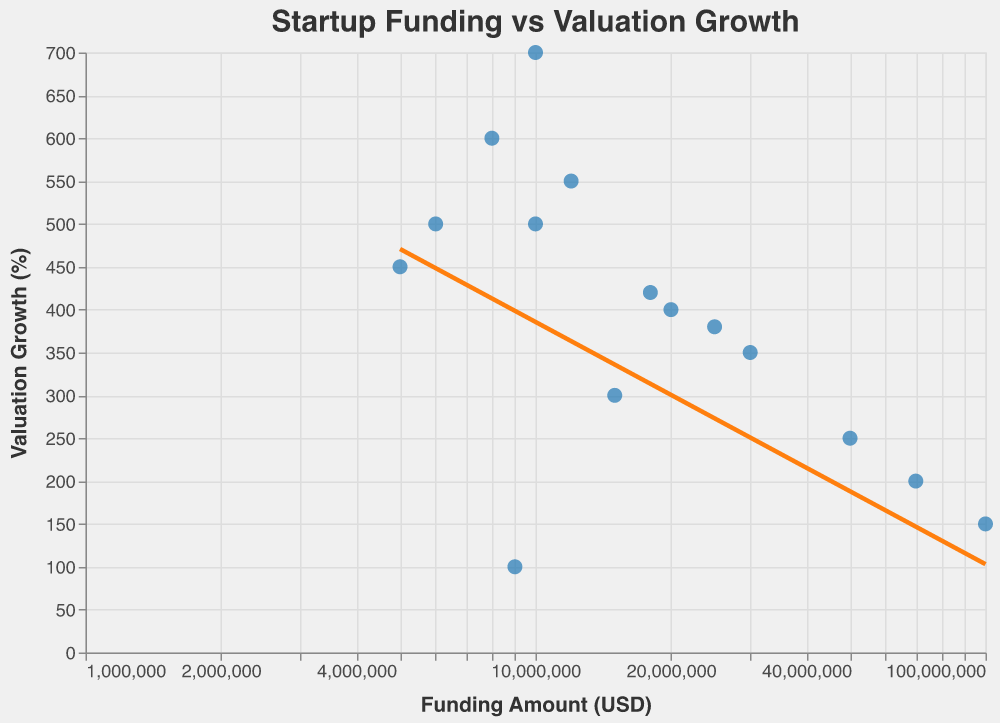What is the funding amount with the highest valuation growth? The funding amount with the highest valuation growth corresponds to the data point where "Funding Amount (USD)" has the highest y-value on the vertical axis, which is at 700% valuation growth for SpaceX with $10,000,000.
Answer: $10,000,000 Which startup received the highest funding amount? The highest funding amount can be identified by locating the rightmost data point on the x-axis, which is for Snapchat with $100,000,000.
Answer: Snapchat What is the trend in valuation growth as funding amount increases? The trend line in the scatter plot generally slopes downwards, indicating a negative correlation between funding amount and valuation growth percentage. Valuation growth tends to decrease as funding amount increases.
Answer: Negative correlation How many startups received more than $20,000,000 in funding? Count the number of data points to the right of the $20,000,000 mark on the x-axis. There are five: Airbnb, Slack, Dropbox, Coinbase, Snapchat, and Lyft.
Answer: 6 What is the valuation growth percentage of the startup with the lowest funding amount? Locate the leftmost data point on the x-axis, which corresponds to Stripe with $5,000,000 in funding, and note its y-value. Its valuation growth percentage is 450%.
Answer: 450% Which startup has a higher valuation growth, Uber or Airbnb? Compare the y-values of the data points for Uber and Airbnb. Uber has a higher valuation growth percentage (600%) compared to Airbnb (400%).
Answer: Uber By how much does SpaceX's valuation growth exceed Dropbox's valuation growth? Subtract Dropbox's valuation growth percentage (200%) from SpaceX's valuation growth percentage (700%) to find the difference. 700% - 200% = 500%.
Answer: 500% Which startup has the lowest valuation growth percentage? Identify the data point with the lowest y-value on the vertical axis, which is for WeWork with a valuation growth percentage of 100%.
Answer: WeWork What is the average valuation growth percentage for the startups with funding amounts between $5,000,000 and $20,000,000? Identify and sum the valuation growth percentages of Stripe (450%), Uber (600%), Peloton (500%), Zoom (500%), WeWork (100%), Robinhood (550%), and DoorDash (420%): 450 + 600 + 500 + 500 + 100 + 550 + 420 = 3120. The count of startups is 7, therefore the average is 3120 / 7 = 445.71%.
Answer: 445.71% 